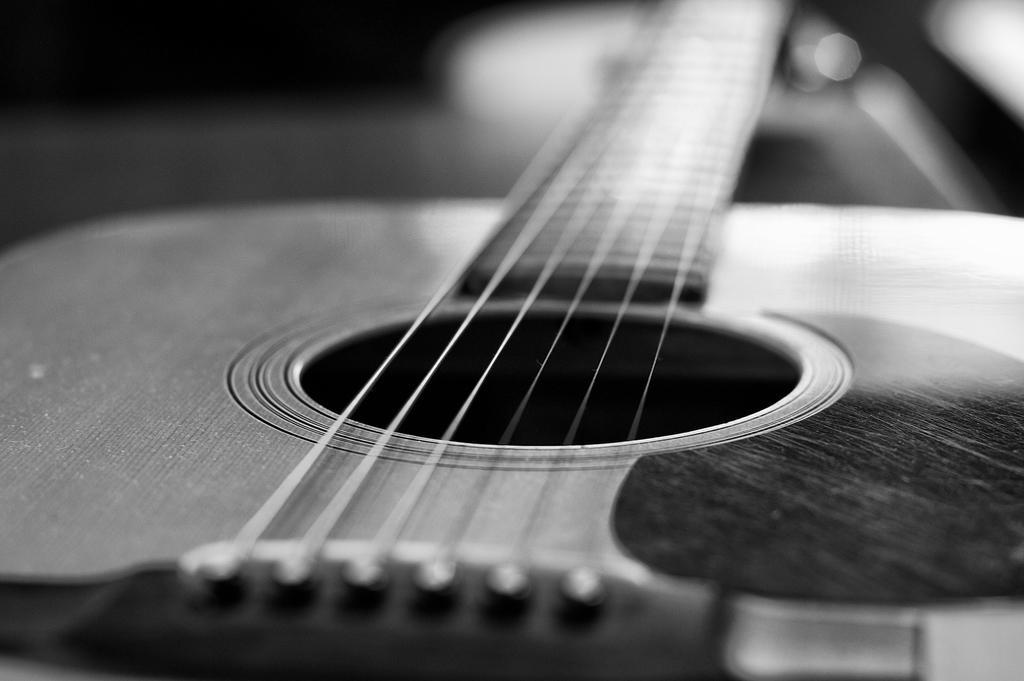Could you give a brief overview of what you see in this image? In the image we can see there is a guitar which is kept on the table and the image is in black and white colour. 